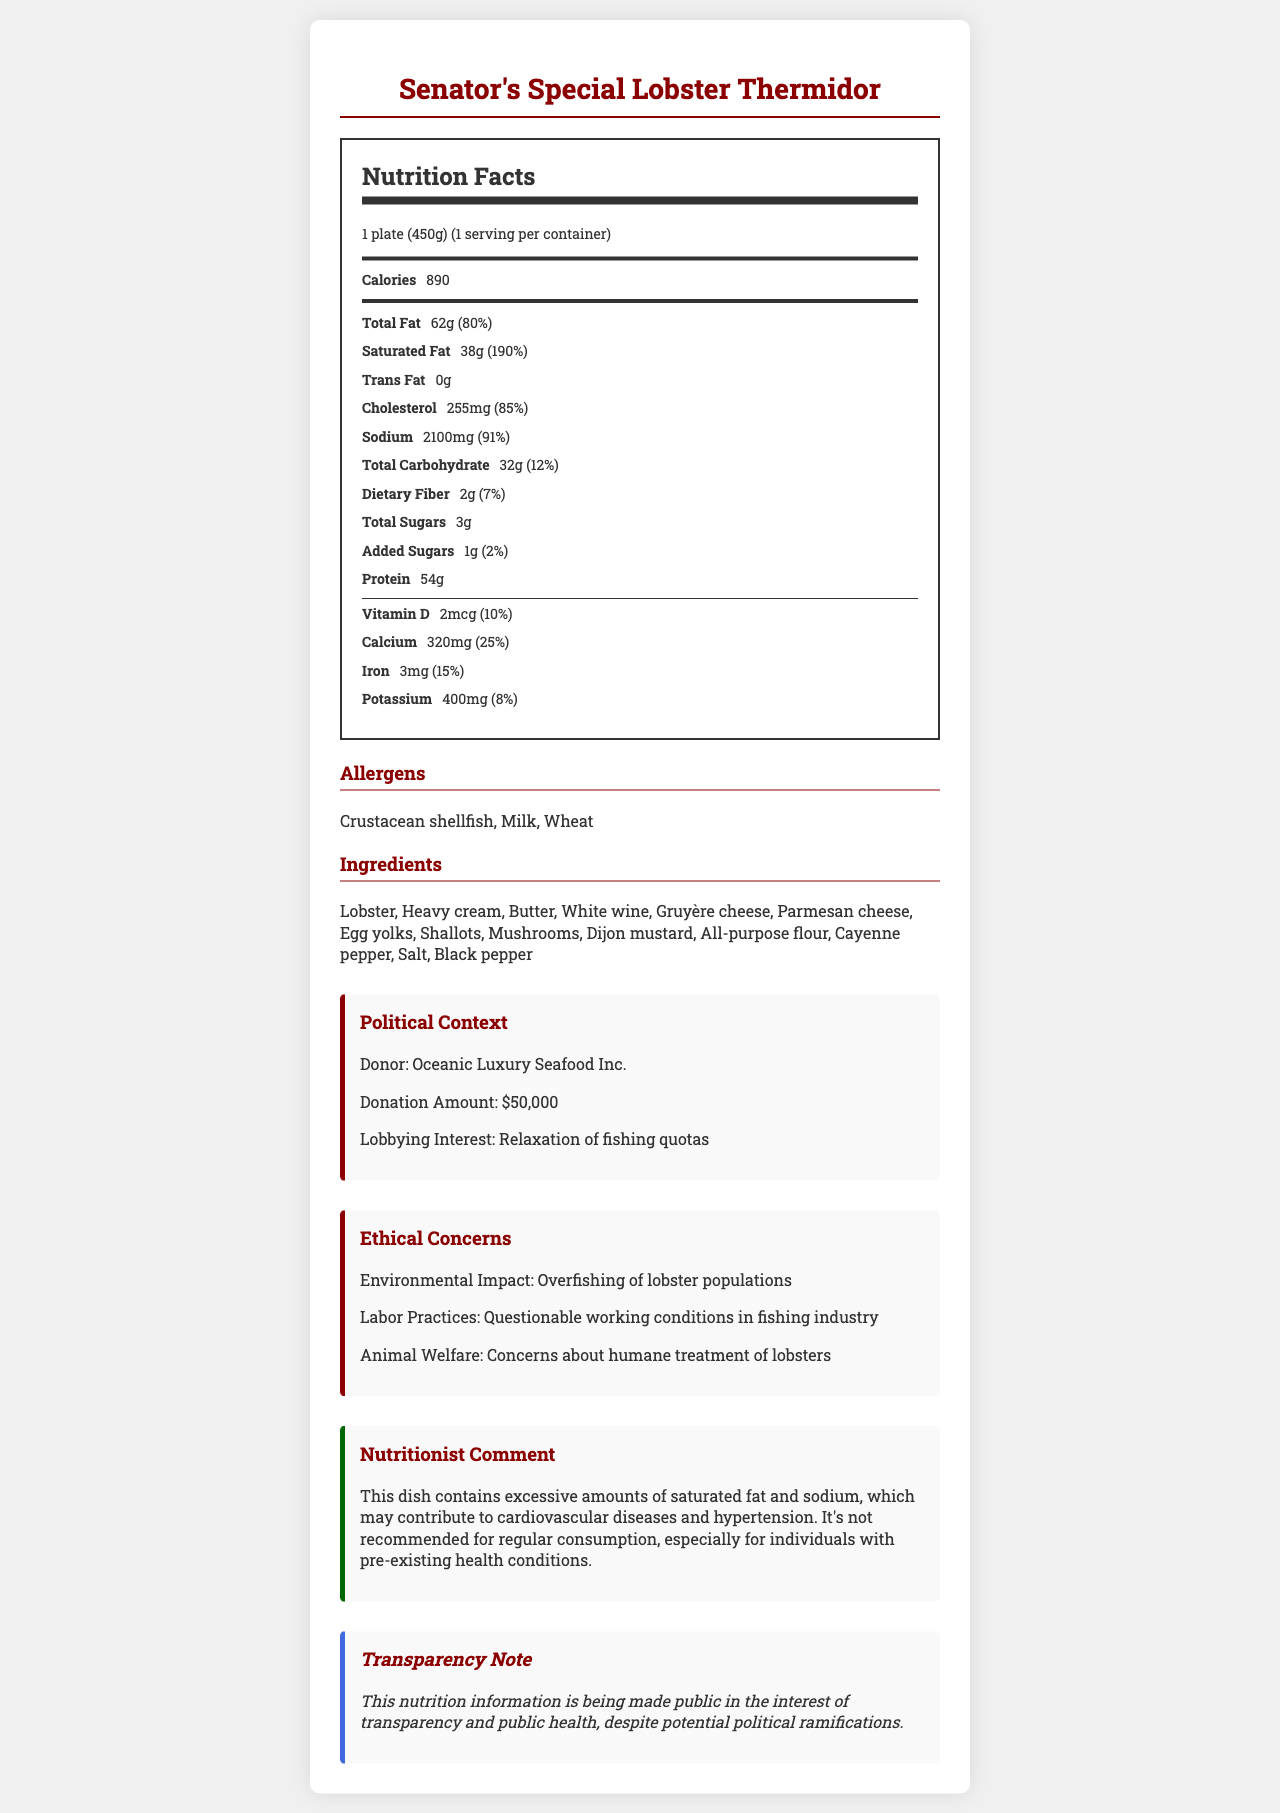what is the serving size for the Senator's Special Lobster Thermidor? The serving size is explicitly stated as "1 plate (450g)" at the top of the nutrition label section.
Answer: 1 plate (450g) how many calories are in one serving? The calories per serving are listed as 890, directly under the serving size and servings per container information.
Answer: 890 what is the amount of sodium per serving? The sodium content is specified as 2100mg in the nutrition facts section.
Answer: 2100mg which nutrient has the highest daily value percentage? The daily value for saturated fat is 190%, which is higher than any other nutrient listed.
Answer: Saturated Fat at 190% which ingredient is NOT included in the Senator's Special Lobster Thermidor? A. Shrimp B. Lobster C. Butter D. Gruyère cheese The ingredients listed include Lobster, Butter, and Gruyère cheese but do not mention Shrimp.
Answer: A. Shrimp who is the donor mentioned in the political context? The donor name is stated as "Oceanic Luxury Seafood Inc." in the political context section.
Answer: Oceanic Luxury Seafood Inc. what is the total carbohydrate content per serving? The total carbohydrate content per serving is listed as 32g in the nutrition facts.
Answer: 32g does this dish contain any trans fat? True or False The nutrition facts label shows that the dish contains 0g of trans fat.
Answer: False summarize the main health concern highlighted by the nutritionist. The nutritionist's comment states that the dish contains excessive amounts of saturated fat and sodium, potentially contributing to cardiovascular diseases and hypertension, making it not recommended for regular consumption.
Answer: The dish is high in saturated fat and sodium which can contribute to cardiovascular diseases and hypertension. what is the lobbying interest of the donor mentioned in the document? The lobbying interest of Oceanic Luxury Seafood Inc. is stated as the relaxation of fishing quotas in the political context section.
Answer: Relaxation of fishing quotas how much added sugar is present per serving? The added sugar content per serving is listed as 1g in the nutrition facts.
Answer: 1g which ethical concern is NOT mentioned in the document? A. Overfishing B. Child labor C. Labor practices D. Animal welfare The ethical concerns listed are Overfishing, Labor Practices, and Animal Welfare, but there is no mention of Child labor.
Answer: B. Child labor what is the cholesterol content in milligrams? The cholesterol content is specified as 255mg in the nutrition facts section.
Answer: 255mg what allergens are present in this dish? The allergens section lists Crustacean shellfish, Milk, and Wheat as allergens present in this dish.
Answer: Crustacean shellfish, Milk, Wheat how many micrograms of vitamin D are in one serving? The vitamin D content per serving is listed as 2mcg in the nutrition facts.
Answer: 2mcg what is the total protein content in grams? The protein content per serving is listed as 54g in the nutrition facts.
Answer: 54g how many daily values are given for total carbohydrates? The daily value for total carbohydrates is listed as 12% in the nutrition facts.
Answer: 12% why is the nutrition information being made public? According to the transparency note, the nutrition information is being made public in the interest of transparency and public health, despite potential political ramifications.
Answer: In the interest of transparency and public health how many different cheeses are listed in the ingredients? The ingredients list includes Gruyère cheese and Parmesan cheese, making it two different types of cheese.
Answer: Two: Gruyère cheese and Parmesan cheese what is the environmental impact associated with the dish? The environmental impact mentioned is the overfishing of lobster populations, as stated in the ethical concerns section.
Answer: Overfishing of lobster populations is there enough information to determine the exact amount of salt used in the recipe? The document provides total sodium content but does not specify the exact amount of salt used in the recipe.
Answer: Not enough information 